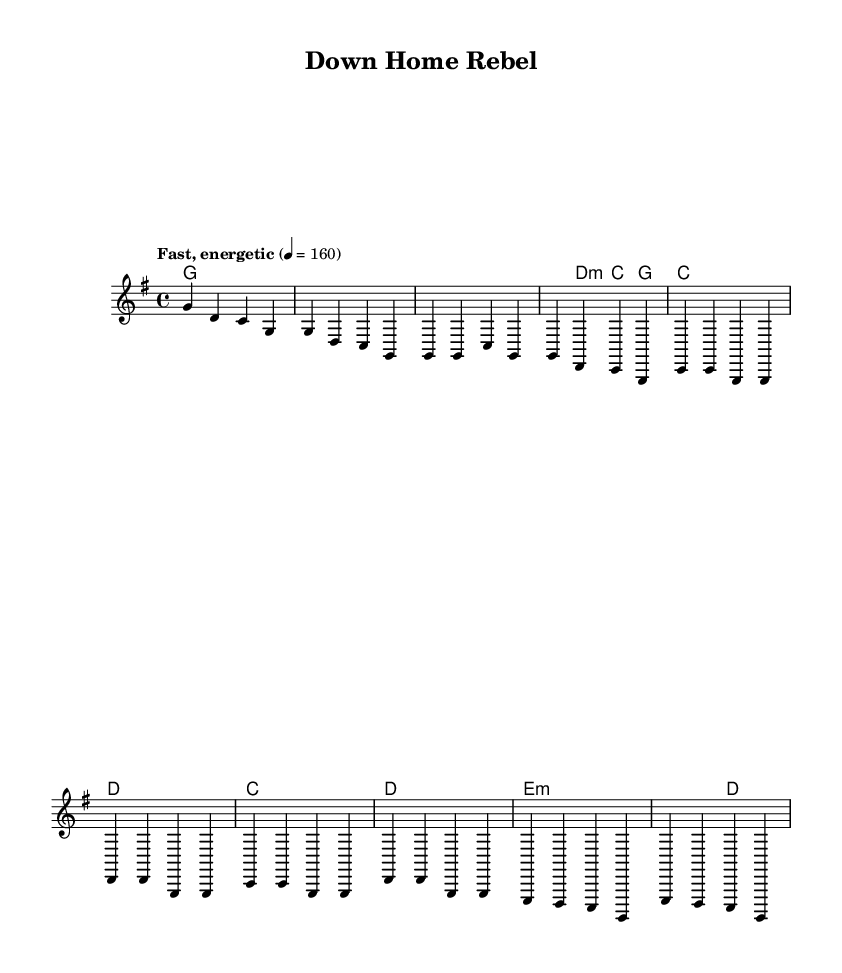What is the key signature of this music? The key signature is G major, which has one sharp (F#). This is determined by examining the global section in the provided sheet music where it states "\key g \major."
Answer: G major What is the time signature of the piece? The time signature is 4/4, which indicates that there are four beats in each measure. This is also found in the global section where it states "\time 4/4."
Answer: 4/4 What is the tempo marking for this piece? The tempo marking states "Fast, energetic," which directs the performer to play the piece with a lively and spirited feel. The specific tempo is indicated as 4 = 160, meaning there are 160 quarter-note beats per minute. This information is listed in the global section under tempo.
Answer: Fast, energetic Which chords are played during the chorus? During the chorus, the chords are C and D. Each chord is noted in the harmonies section of the sheet music, corresponding to the melody phrases "c4 c g g" (C) followed by "d' d g, g" (D).
Answer: C, D What section follows the verse in the song structure? The section that follows the verse is the chorus. This is determined by reviewing the structure indicated in the melody section, where the sequence begins to repeat with "c4 c g g" and continues with "d' d g, g" immediately after the verse phrases.
Answer: Chorus What is the nature of the bridge section in terms of harmony? The harmony during the bridge utilizes minor chords, specifically E minor. This can be seen in the harmonies section where it is indicated as "e1:m," establishing a contrast to the earlier sections that mostly use major chords. This signifies a shift in mood typical in bluegrass-punk fusion.
Answer: Minor chords 